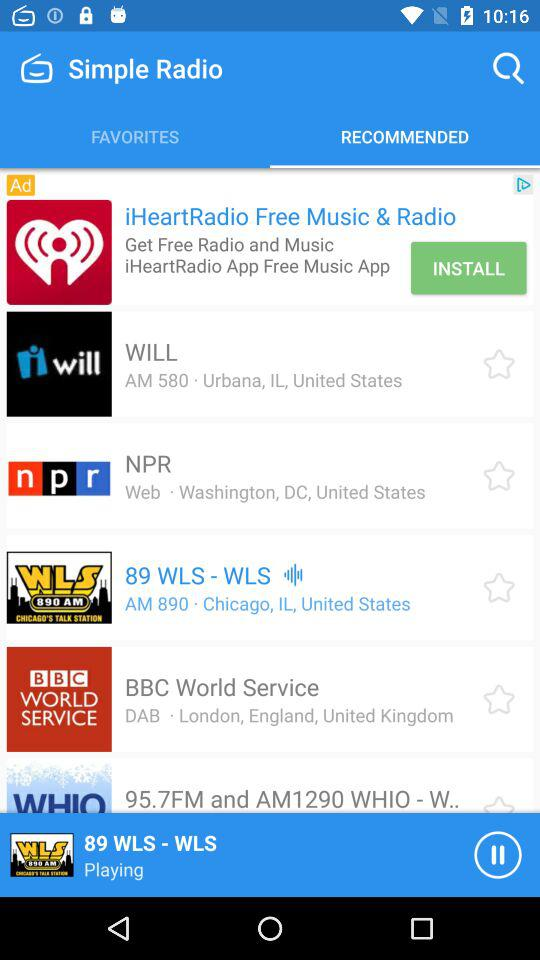What is the location of "BBC World Service"? The location of "BBC World Service" is London, England, United Kingdom. 